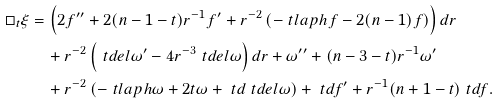Convert formula to latex. <formula><loc_0><loc_0><loc_500><loc_500>\Box _ { t } \xi & = \left ( 2 f ^ { \prime \prime } + 2 ( n - 1 - t ) r ^ { - 1 } f ^ { \prime } + r ^ { - 2 } \left ( - \ t l a p h f - 2 ( n - 1 ) f \right ) \right ) d r \\ & \quad + r ^ { - 2 } \left ( \ t d e l \omega ^ { \prime } - 4 r ^ { - 3 } \ t d e l \omega \right ) d r + \omega ^ { \prime \prime } + ( n - 3 - t ) r ^ { - 1 } \omega ^ { \prime } \\ & \quad + r ^ { - 2 } \left ( - \ t l a p h \omega + 2 t \omega + \ t d \ t d e l \omega \right ) + \ t d f ^ { \prime } + r ^ { - 1 } ( n + 1 - t ) \ t d f .</formula> 